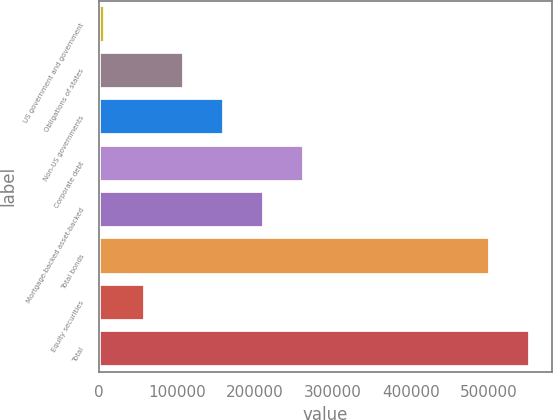Convert chart. <chart><loc_0><loc_0><loc_500><loc_500><bar_chart><fcel>US government and government<fcel>Obligations of states<fcel>Non-US governments<fcel>Corporate debt<fcel>Mortgage-backed asset-backed<fcel>Total bonds<fcel>Equity securities<fcel>Total<nl><fcel>7956<fcel>109776<fcel>160687<fcel>262507<fcel>211597<fcel>501870<fcel>58866.2<fcel>552780<nl></chart> 